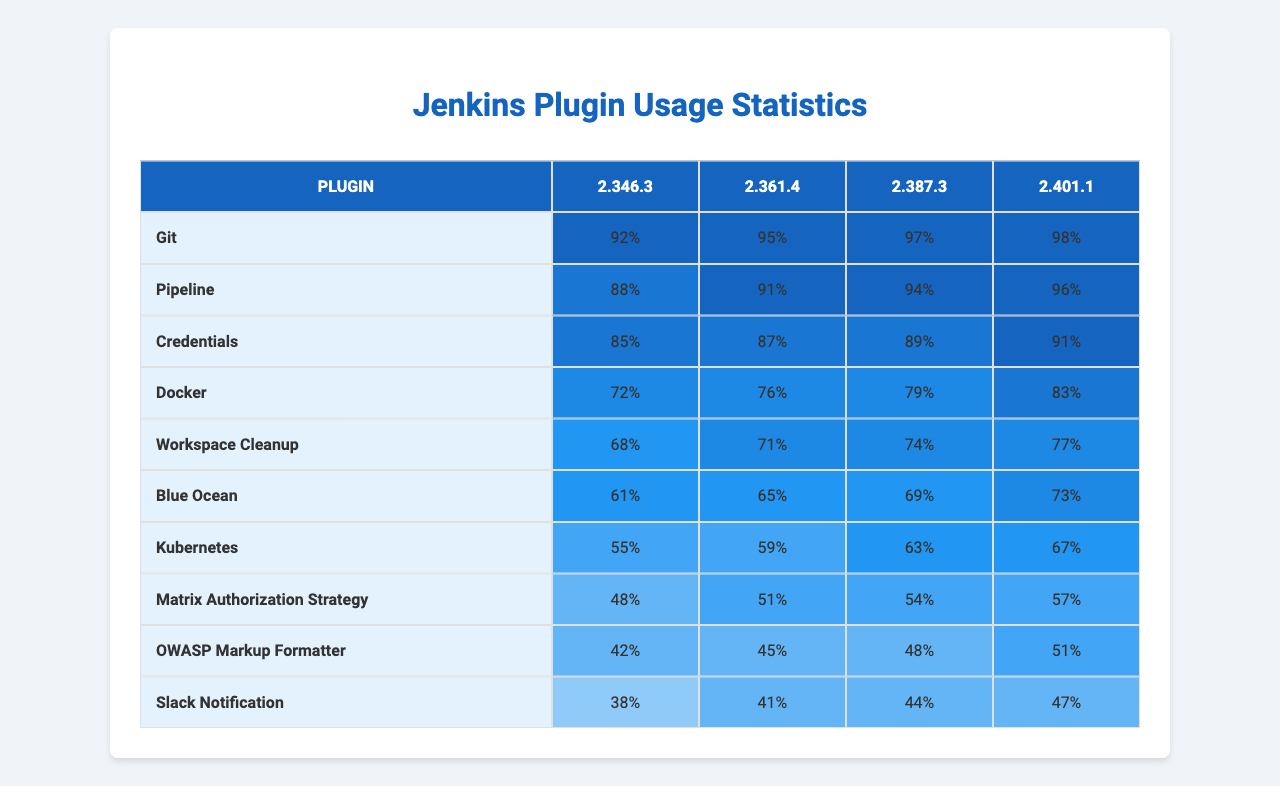What is the usage percentage of the Git plugin in version 2.401.1? In the table, the usage percentage for the Git plugin is listed in the last column corresponding to version 2.401.1. It shows a value of 98%.
Answer: 98% Which plugin has the lowest usage percentage in version 2.346.3? To find the lowest usage percentage in version 2.346.3, we compare the first column with the values under the 2.346.3 header. The Kubernetes plugin has the lowest usage at 55%.
Answer: 55% What is the average usage percentage of the Pipeline plugin across all versions? The usage percentages for the Pipeline plugin are 95%, 91%, 87%, and 76%. First, we sum these values: 95 + 91 + 87 + 76 = 349. Next, we divide by 4 (the number of versions): 349 / 4 = 87.25%.
Answer: 87.25% Is the usage percentage of the Docker plugin greater in version 2.361.4 compared to the version 2.387.3? In the table, the usage percentage for the Docker plugin in version 2.361.4 is 94%, while in version 2.387.3 it is 89%. Thus, 94% > 89%, so the statement is true.
Answer: Yes What is the total usage percentage of all plugins in version 2.401.1? To find the total, we add the usage percentages of all plugins for version 2.401.1, which are 98%, 96%, 91%, 83%, 77%, 73%, 67%, 57%, 51%, and 47%. Summing these gives 98 + 96 + 91 + 83 + 77 + 73 + 67 + 57 + 51 + 47 = 540%.
Answer: 540% Which two plugins have the highest and lowest usage in version 2.387.3? In version 2.387.3, the highest usage is for the Git plugin at 97% and the lowest is for the Slack Notification plugin at 44%.
Answer: Git: 97%, Slack Notification: 44% If the usage of the Blue Ocean plugin in version 2.346.3 increases by 5%, what will its new percentage be? The current usage percentage of the Blue Ocean plugin in version 2.346.3 is 61%. Increasing this by 5% would result in 61% + 5% = 66%.
Answer: 66% What is the percentage difference in usage for the Credentials plugin between version 2.401.1 and 2.346.3? The usage percentage for the Credentials plugin in version 2.401.1 is 83% and in version 2.346.3 it is 72%. The difference is 83% - 72% = 11%.
Answer: 11% For which plugin does the usage drop from version 2.361.4 to 2.387.3? Looking at the table, the usage for the Workspace Cleanup plugin drops from 71% in version 2.361.4 to 68% in 2.387.3.
Answer: Workspace Cleanup What is the trend of the Kubernetes plugin usage from version 2.346.3 to 2.401.1? The Kubernetes plugin usage is 59% in version 2.346.3 and increases to 67% in version 2.401.1. Therefore, the trend shows a positive increase of 8%.
Answer: Increase Which plugin's usage is consistently above 70% across all versions? Analyzing the table, the Git plugin has usage percentages of 92%, 95%, 97%, and 98%, all of which are above 70%.
Answer: Git 